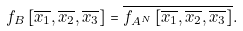<formula> <loc_0><loc_0><loc_500><loc_500>f _ { B } \left [ \overline { x _ { 1 } } , \overline { x _ { 2 } } , \overline { x _ { 3 } } \right ] = \overline { f _ { A ^ { N } } \left [ \overline { x _ { 1 } } , \overline { x _ { 2 } } , \overline { x _ { 3 } } \right ] } .</formula> 